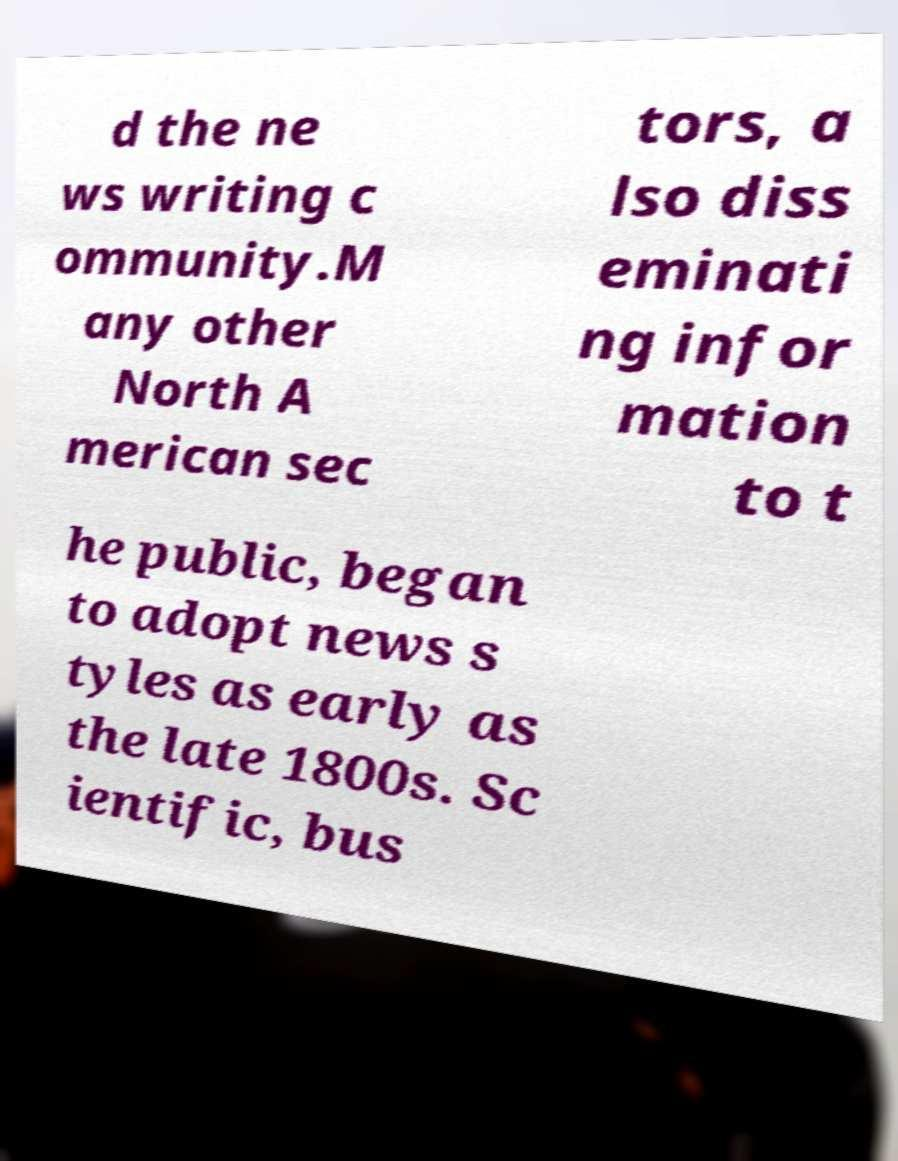For documentation purposes, I need the text within this image transcribed. Could you provide that? d the ne ws writing c ommunity.M any other North A merican sec tors, a lso diss eminati ng infor mation to t he public, began to adopt news s tyles as early as the late 1800s. Sc ientific, bus 